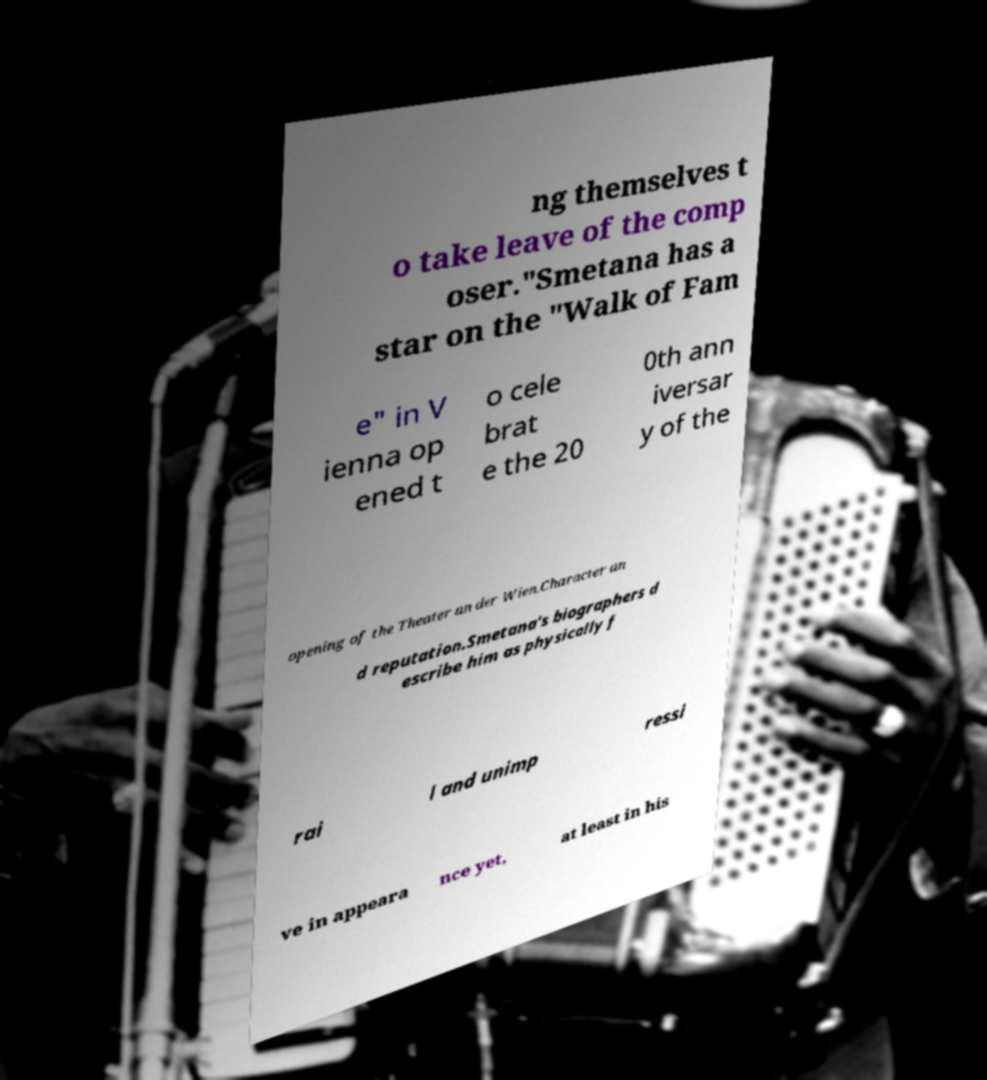Please read and relay the text visible in this image. What does it say? ng themselves t o take leave of the comp oser."Smetana has a star on the "Walk of Fam e" in V ienna op ened t o cele brat e the 20 0th ann iversar y of the opening of the Theater an der Wien.Character an d reputation.Smetana's biographers d escribe him as physically f rai l and unimp ressi ve in appeara nce yet, at least in his 